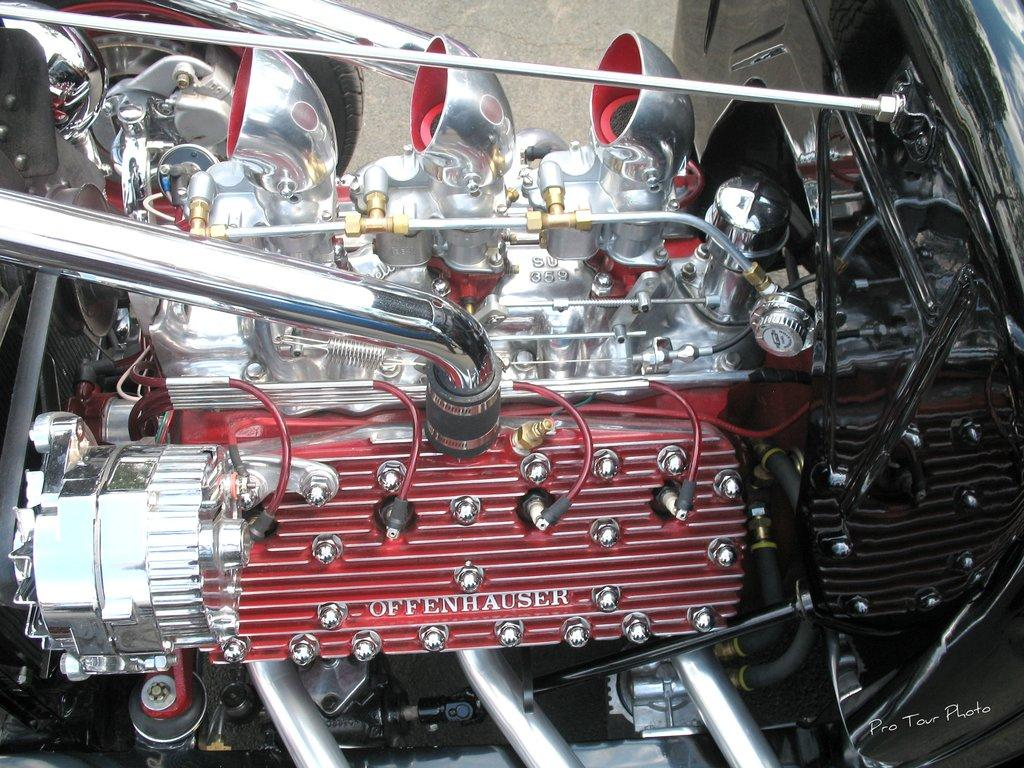What is the main subject of the image? There is a vehicle in the image. How is the vehicle positioned in the image? The vehicle is shown from the front side. What can be seen in the background of the image? There is a wall visible in the background of the image. What type of self-driving technology is being demonstrated by the vehicle in the image? There is no indication in the image that the vehicle is self-driving or demonstrating any specific technology. 